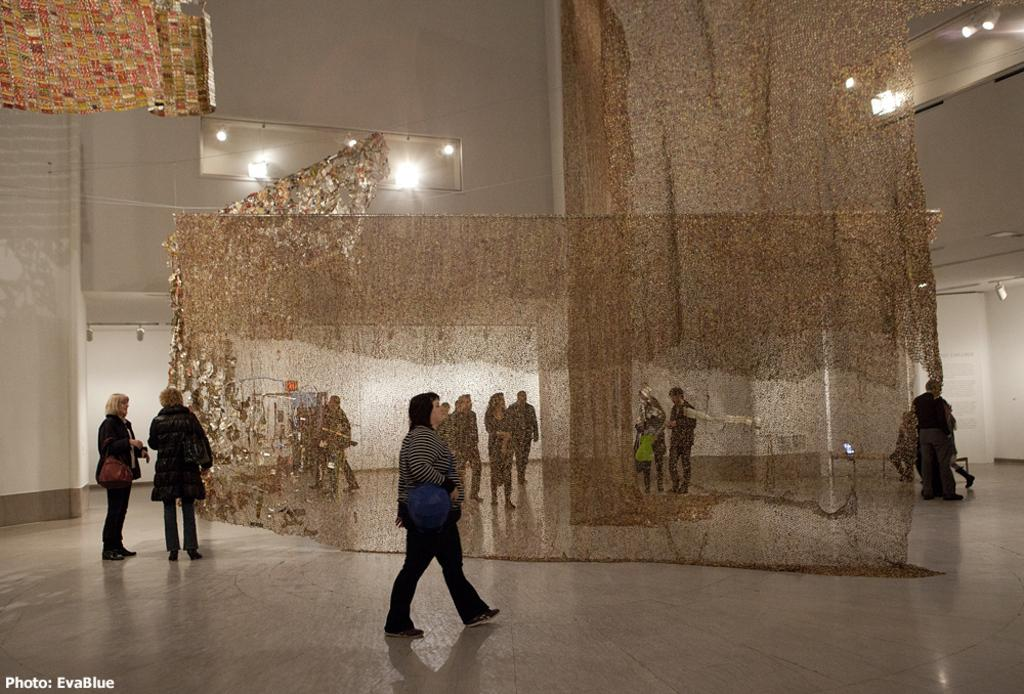Who or what is present in the image? There are people in the image. What can be seen in the foreground of the image? There are curtains in the foreground area of the image. What is visible in the background of the image? There are lamps and people in the background of the image. What type of sign is hanging on the wall in the image? There is no sign visible in the image. What color is the shirt worn by the person in the image? The provided facts do not mention the color of any shirts worn by the people in the image. 